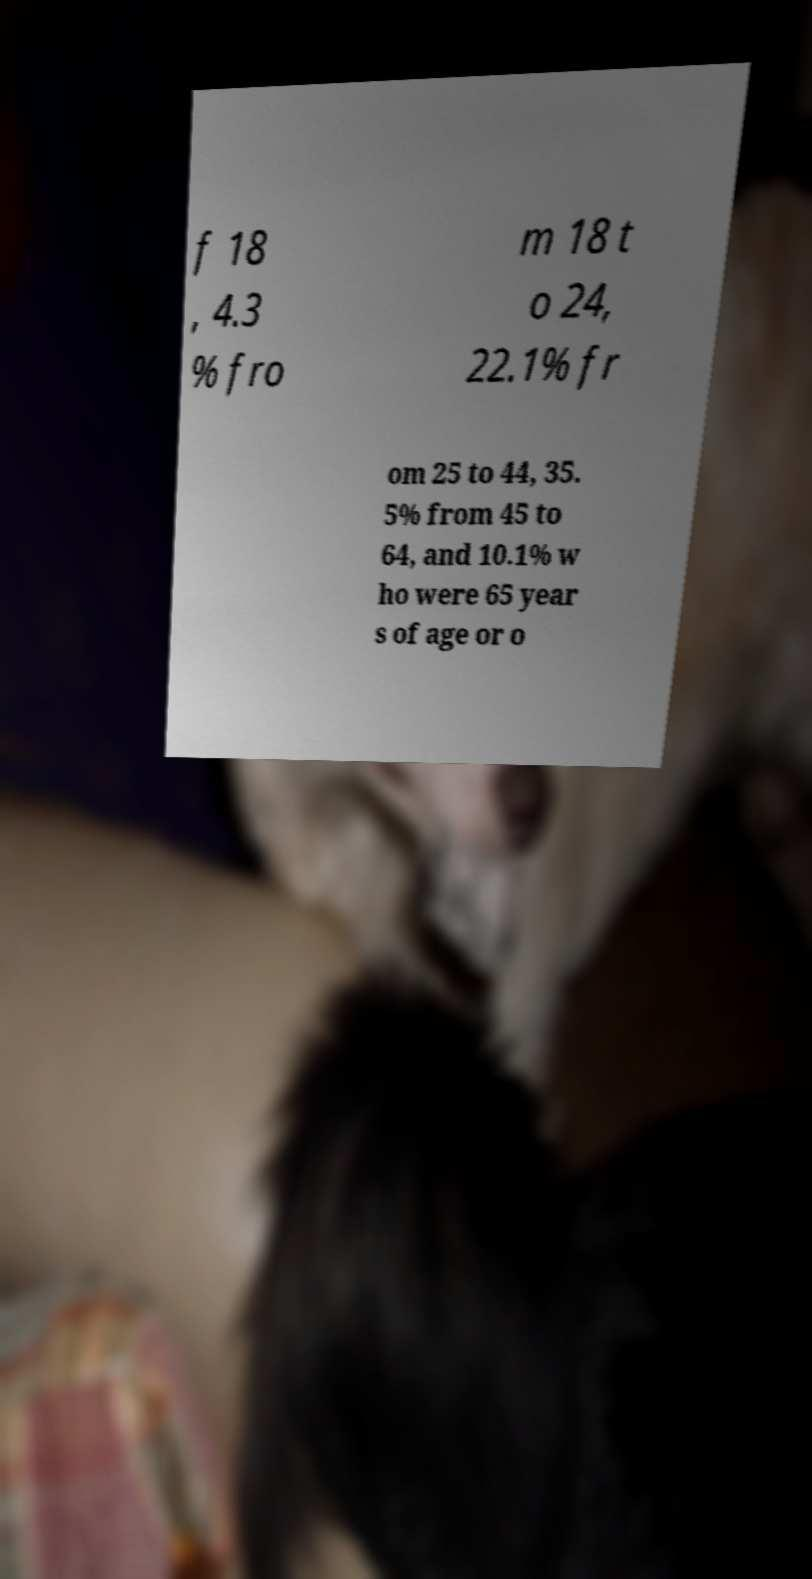For documentation purposes, I need the text within this image transcribed. Could you provide that? f 18 , 4.3 % fro m 18 t o 24, 22.1% fr om 25 to 44, 35. 5% from 45 to 64, and 10.1% w ho were 65 year s of age or o 